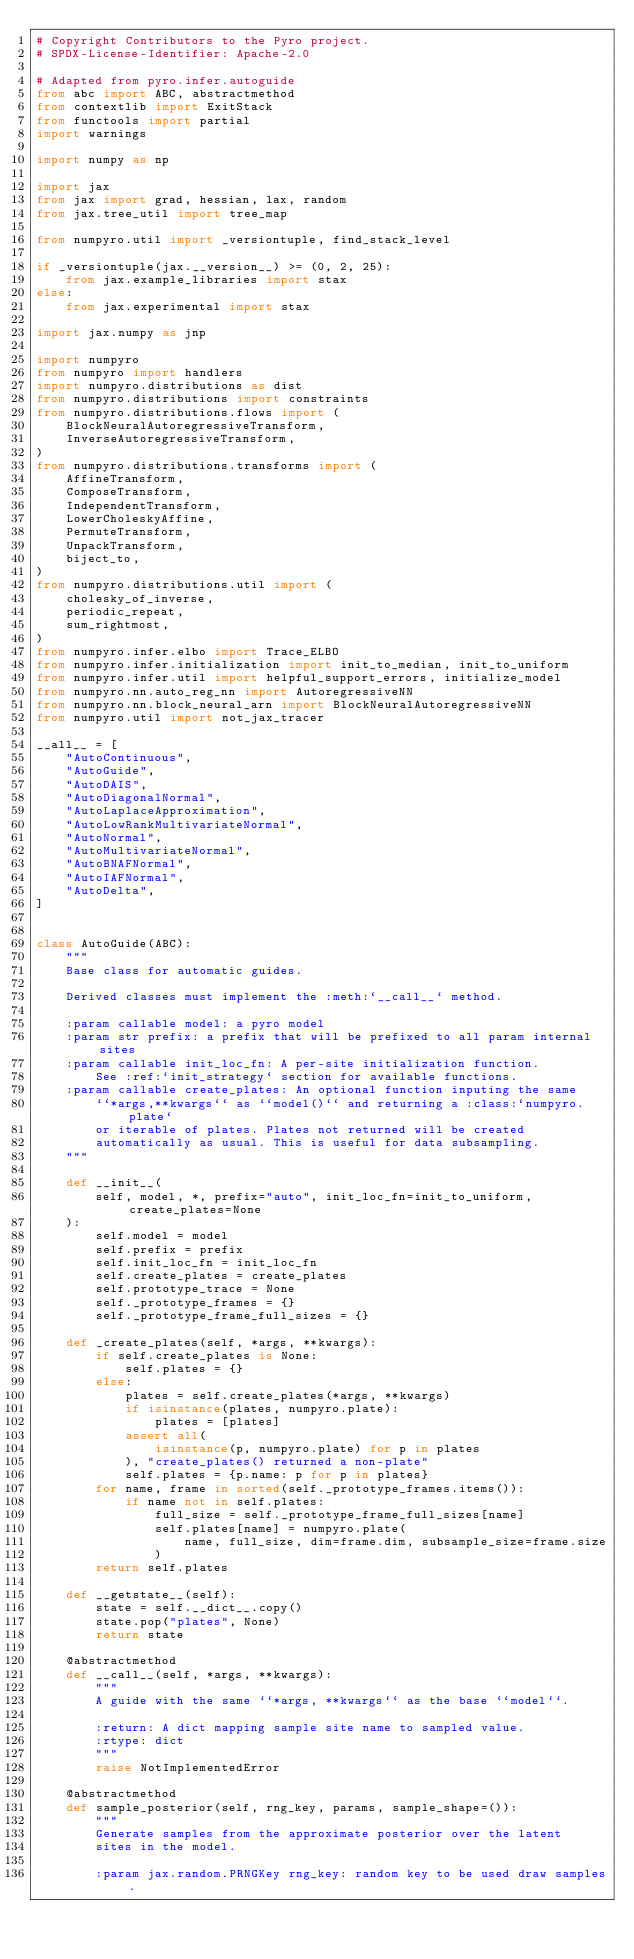Convert code to text. <code><loc_0><loc_0><loc_500><loc_500><_Python_># Copyright Contributors to the Pyro project.
# SPDX-License-Identifier: Apache-2.0

# Adapted from pyro.infer.autoguide
from abc import ABC, abstractmethod
from contextlib import ExitStack
from functools import partial
import warnings

import numpy as np

import jax
from jax import grad, hessian, lax, random
from jax.tree_util import tree_map

from numpyro.util import _versiontuple, find_stack_level

if _versiontuple(jax.__version__) >= (0, 2, 25):
    from jax.example_libraries import stax
else:
    from jax.experimental import stax

import jax.numpy as jnp

import numpyro
from numpyro import handlers
import numpyro.distributions as dist
from numpyro.distributions import constraints
from numpyro.distributions.flows import (
    BlockNeuralAutoregressiveTransform,
    InverseAutoregressiveTransform,
)
from numpyro.distributions.transforms import (
    AffineTransform,
    ComposeTransform,
    IndependentTransform,
    LowerCholeskyAffine,
    PermuteTransform,
    UnpackTransform,
    biject_to,
)
from numpyro.distributions.util import (
    cholesky_of_inverse,
    periodic_repeat,
    sum_rightmost,
)
from numpyro.infer.elbo import Trace_ELBO
from numpyro.infer.initialization import init_to_median, init_to_uniform
from numpyro.infer.util import helpful_support_errors, initialize_model
from numpyro.nn.auto_reg_nn import AutoregressiveNN
from numpyro.nn.block_neural_arn import BlockNeuralAutoregressiveNN
from numpyro.util import not_jax_tracer

__all__ = [
    "AutoContinuous",
    "AutoGuide",
    "AutoDAIS",
    "AutoDiagonalNormal",
    "AutoLaplaceApproximation",
    "AutoLowRankMultivariateNormal",
    "AutoNormal",
    "AutoMultivariateNormal",
    "AutoBNAFNormal",
    "AutoIAFNormal",
    "AutoDelta",
]


class AutoGuide(ABC):
    """
    Base class for automatic guides.

    Derived classes must implement the :meth:`__call__` method.

    :param callable model: a pyro model
    :param str prefix: a prefix that will be prefixed to all param internal sites
    :param callable init_loc_fn: A per-site initialization function.
        See :ref:`init_strategy` section for available functions.
    :param callable create_plates: An optional function inputing the same
        ``*args,**kwargs`` as ``model()`` and returning a :class:`numpyro.plate`
        or iterable of plates. Plates not returned will be created
        automatically as usual. This is useful for data subsampling.
    """

    def __init__(
        self, model, *, prefix="auto", init_loc_fn=init_to_uniform, create_plates=None
    ):
        self.model = model
        self.prefix = prefix
        self.init_loc_fn = init_loc_fn
        self.create_plates = create_plates
        self.prototype_trace = None
        self._prototype_frames = {}
        self._prototype_frame_full_sizes = {}

    def _create_plates(self, *args, **kwargs):
        if self.create_plates is None:
            self.plates = {}
        else:
            plates = self.create_plates(*args, **kwargs)
            if isinstance(plates, numpyro.plate):
                plates = [plates]
            assert all(
                isinstance(p, numpyro.plate) for p in plates
            ), "create_plates() returned a non-plate"
            self.plates = {p.name: p for p in plates}
        for name, frame in sorted(self._prototype_frames.items()):
            if name not in self.plates:
                full_size = self._prototype_frame_full_sizes[name]
                self.plates[name] = numpyro.plate(
                    name, full_size, dim=frame.dim, subsample_size=frame.size
                )
        return self.plates

    def __getstate__(self):
        state = self.__dict__.copy()
        state.pop("plates", None)
        return state

    @abstractmethod
    def __call__(self, *args, **kwargs):
        """
        A guide with the same ``*args, **kwargs`` as the base ``model``.

        :return: A dict mapping sample site name to sampled value.
        :rtype: dict
        """
        raise NotImplementedError

    @abstractmethod
    def sample_posterior(self, rng_key, params, sample_shape=()):
        """
        Generate samples from the approximate posterior over the latent
        sites in the model.

        :param jax.random.PRNGKey rng_key: random key to be used draw samples.</code> 